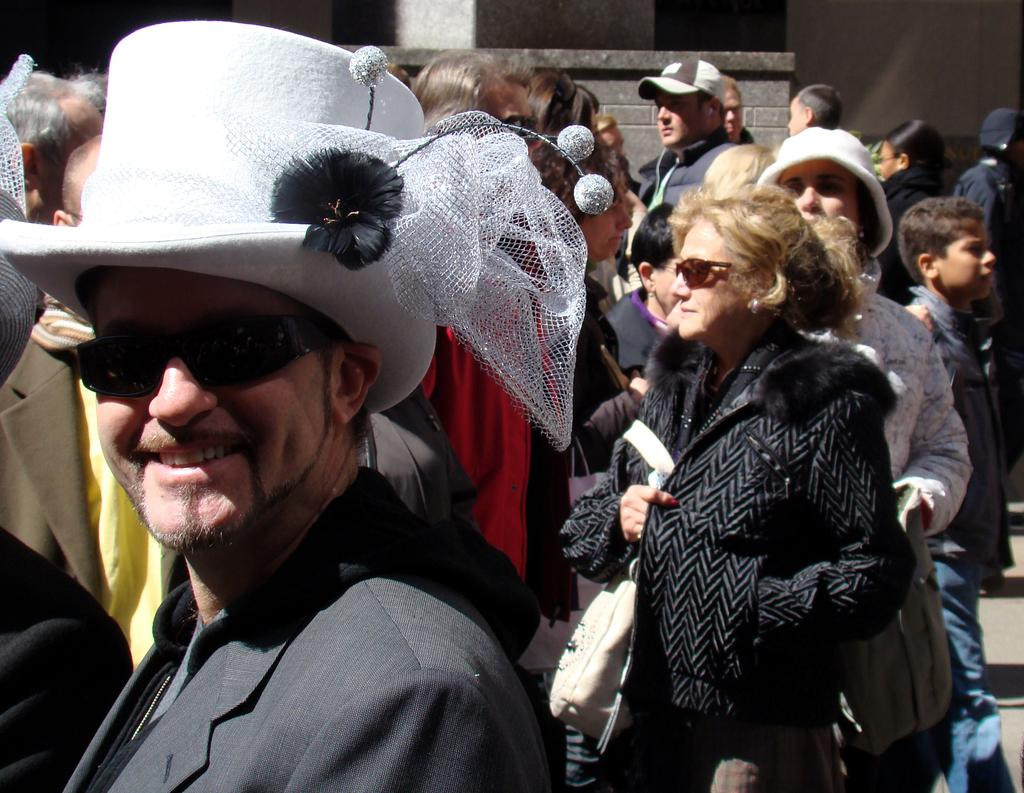What is the person in the foreground of the image wearing? The person is wearing a suit in the image. What type of hat is the person wearing? The person is wearing a white color hat. What can be seen in the background of the image? There are people and a wall in the background of the image. What type of plants can be seen growing under the person's underwear in the image? There is no mention of plants or underwear in the image, so this question cannot be answered. 